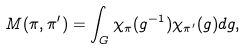Convert formula to latex. <formula><loc_0><loc_0><loc_500><loc_500>M ( \pi , \pi ^ { \prime } ) = \int _ { G } \chi _ { \pi } ( g ^ { - 1 } ) \chi _ { \pi ^ { \prime } } ( g ) d g ,</formula> 